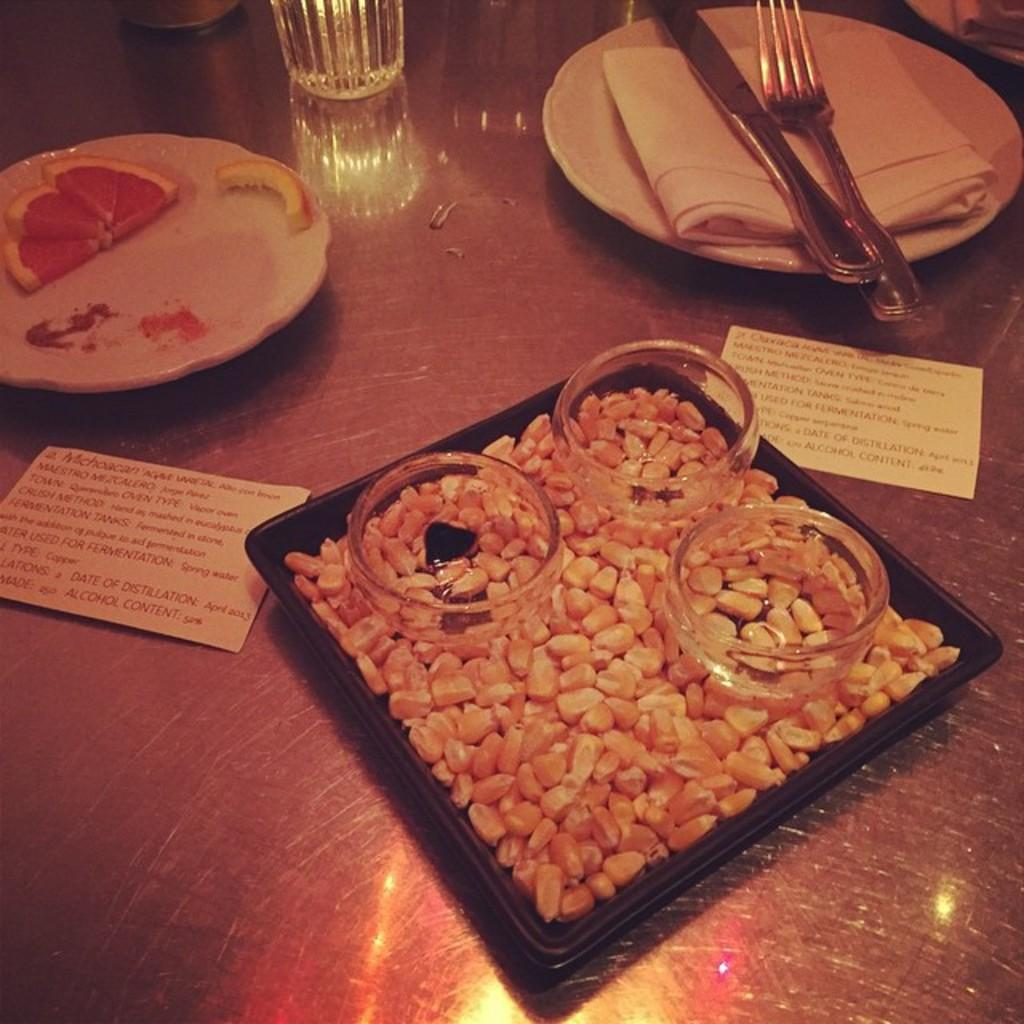What type of objects can be seen on the surface in the image? There are plates, a knife, a fork, bowls, a glass, and cards on the surface in the image. What else is present on the surface besides utensils and tableware? There is food on the surface in the image. What type of thread is being used to hold the banana in the image? There is no banana present in the image, and therefore no thread is being used to hold it. 